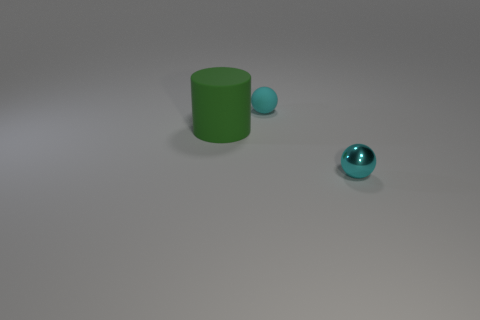What size is the object that is in front of the tiny matte sphere and behind the cyan shiny sphere?
Keep it short and to the point. Large. Is the material of the big green cylinder the same as the ball that is right of the tiny cyan matte thing?
Make the answer very short. No. What number of cyan matte things have the same shape as the small cyan metallic object?
Keep it short and to the point. 1. What is the material of the other object that is the same color as the small matte object?
Ensure brevity in your answer.  Metal. How many big green cylinders are there?
Your answer should be very brief. 1. Do the small rubber object and the cyan object in front of the green matte object have the same shape?
Provide a short and direct response. Yes. How many objects are either big objects or things on the left side of the tiny cyan matte thing?
Ensure brevity in your answer.  1. What is the material of the other tiny cyan thing that is the same shape as the tiny matte object?
Provide a succinct answer. Metal. Do the big green matte object that is on the left side of the tiny metallic thing and the cyan rubber object have the same shape?
Ensure brevity in your answer.  No. Are there any other things that have the same size as the green rubber cylinder?
Provide a succinct answer. No. 